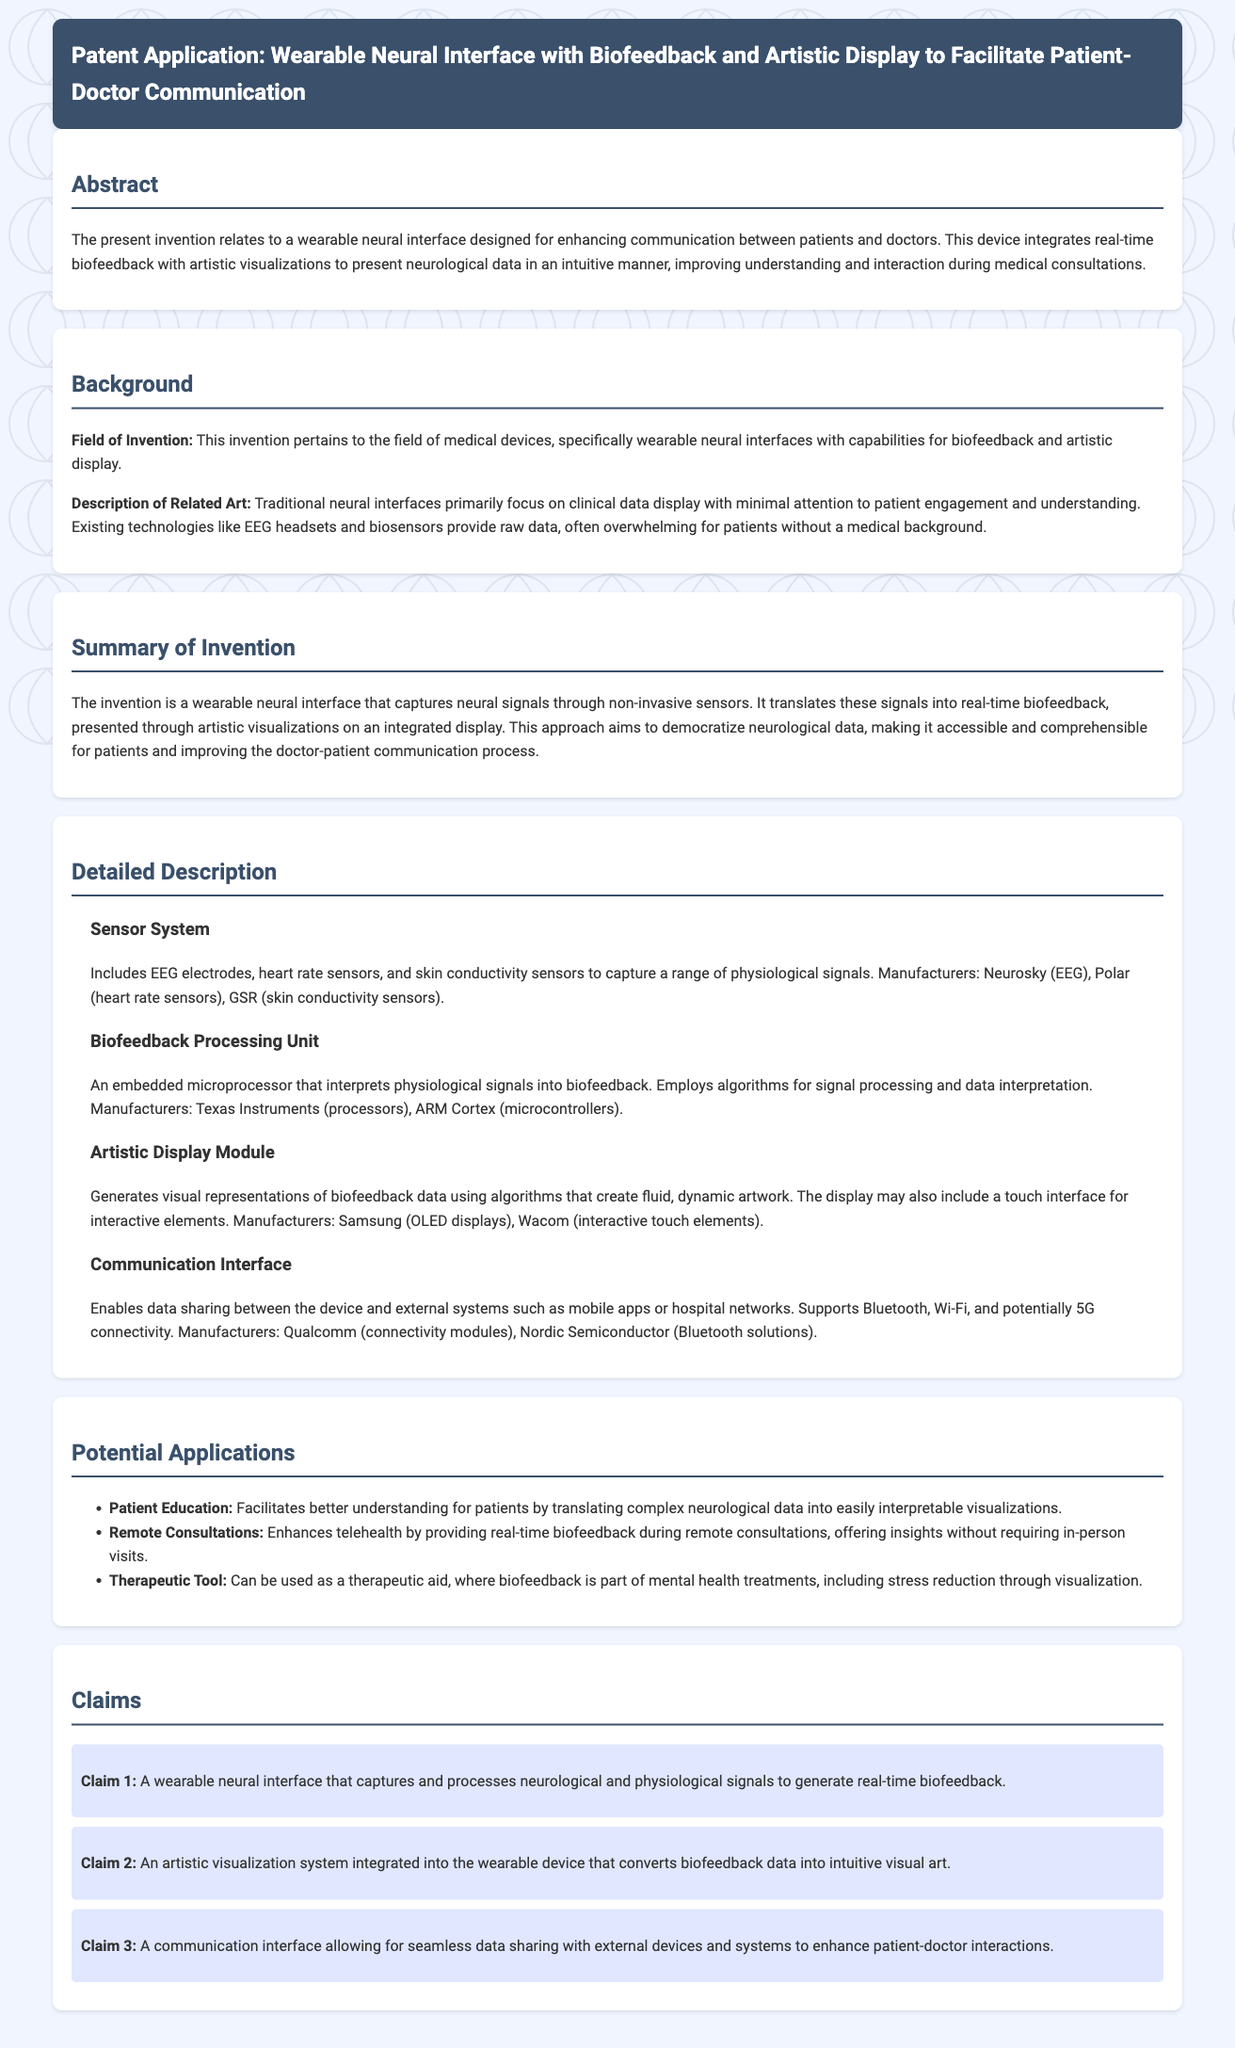What is the title of the patent application? The title is the main heading in the document that defines the subject of the patent.
Answer: Wearable Neural Interface with Biofeedback and Artistic Display to Facilitate Patient-Doctor Communication What field does the invention pertain to? The field is mentioned in the background section and relates to the type of technology being introduced.
Answer: Medical devices Which company manufactures the EEG electrodes mentioned in the sensor system? The manufacturers are listed in the detailed description section under the respective components.
Answer: Neurosky What is the main function of the artistic display module? The function is described in the detailed description section, highlighting its purpose in the device.
Answer: Generates visual representations of biofeedback data How many claims are made in the patent application? The number of claims is mentioned in the claims section, stating the formal assertions in the application.
Answer: Three What is one potential application of the wearable neural interface listed in the document? The potential application is outlined in a specific section focusing on possible uses of the invention.
Answer: Patient Education What type of sensors are included in the sensor system? The types of sensors are detailed in the respective subsection describing the components of the system.
Answer: EEG electrodes, heart rate sensors, skin conductivity sensors What technology is supported by the communication interface? The supported technologies are mentioned in the description of the communication interface.
Answer: Bluetooth, Wi-Fi, and potentially 5G connectivity 